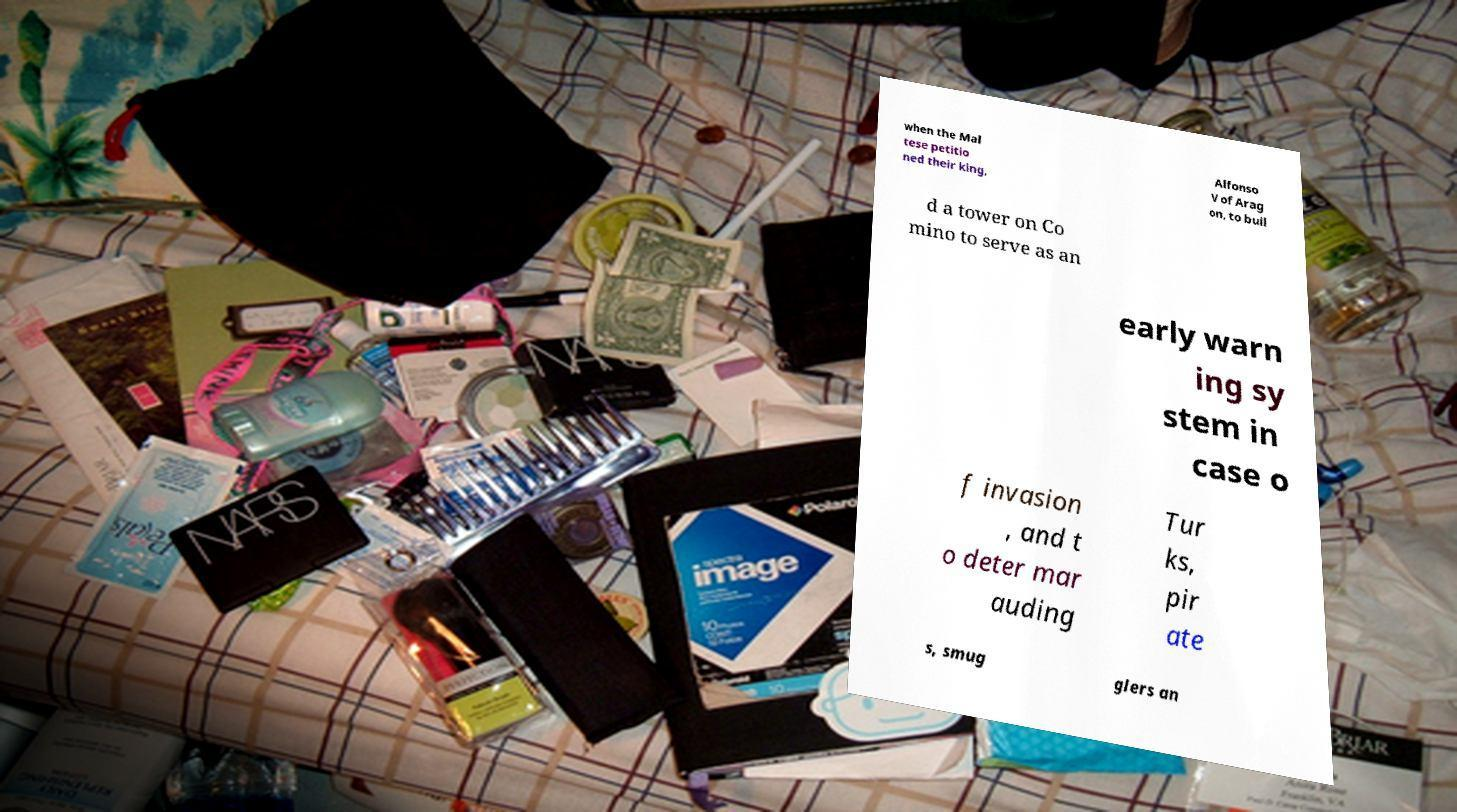What messages or text are displayed in this image? I need them in a readable, typed format. when the Mal tese petitio ned their king, Alfonso V of Arag on, to buil d a tower on Co mino to serve as an early warn ing sy stem in case o f invasion , and t o deter mar auding Tur ks, pir ate s, smug glers an 